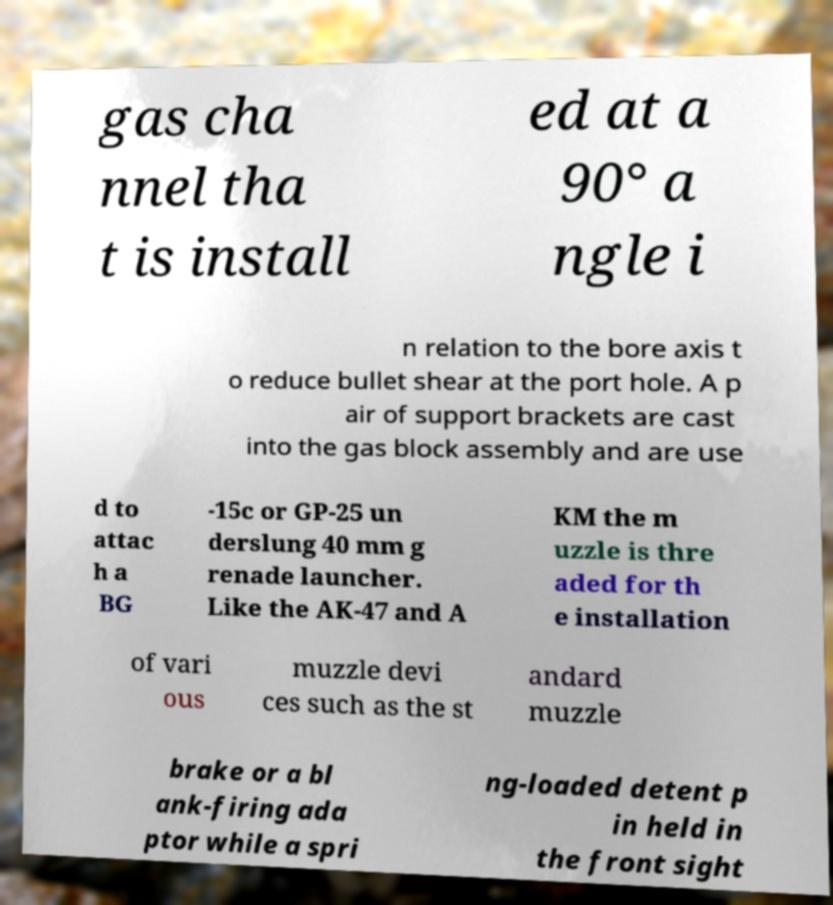Please identify and transcribe the text found in this image. gas cha nnel tha t is install ed at a 90° a ngle i n relation to the bore axis t o reduce bullet shear at the port hole. A p air of support brackets are cast into the gas block assembly and are use d to attac h a BG -15c or GP-25 un derslung 40 mm g renade launcher. Like the AK-47 and A KM the m uzzle is thre aded for th e installation of vari ous muzzle devi ces such as the st andard muzzle brake or a bl ank-firing ada ptor while a spri ng-loaded detent p in held in the front sight 